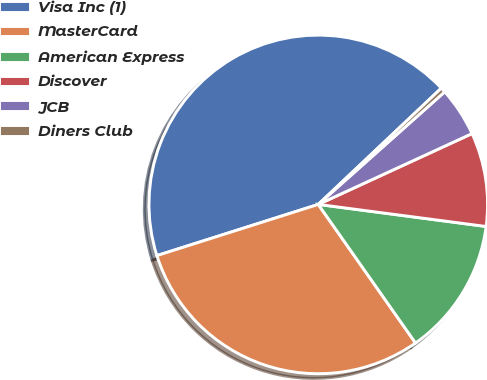Convert chart to OTSL. <chart><loc_0><loc_0><loc_500><loc_500><pie_chart><fcel>Visa Inc (1)<fcel>MasterCard<fcel>American Express<fcel>Discover<fcel>JCB<fcel>Diners Club<nl><fcel>42.84%<fcel>29.85%<fcel>13.18%<fcel>8.95%<fcel>4.71%<fcel>0.47%<nl></chart> 